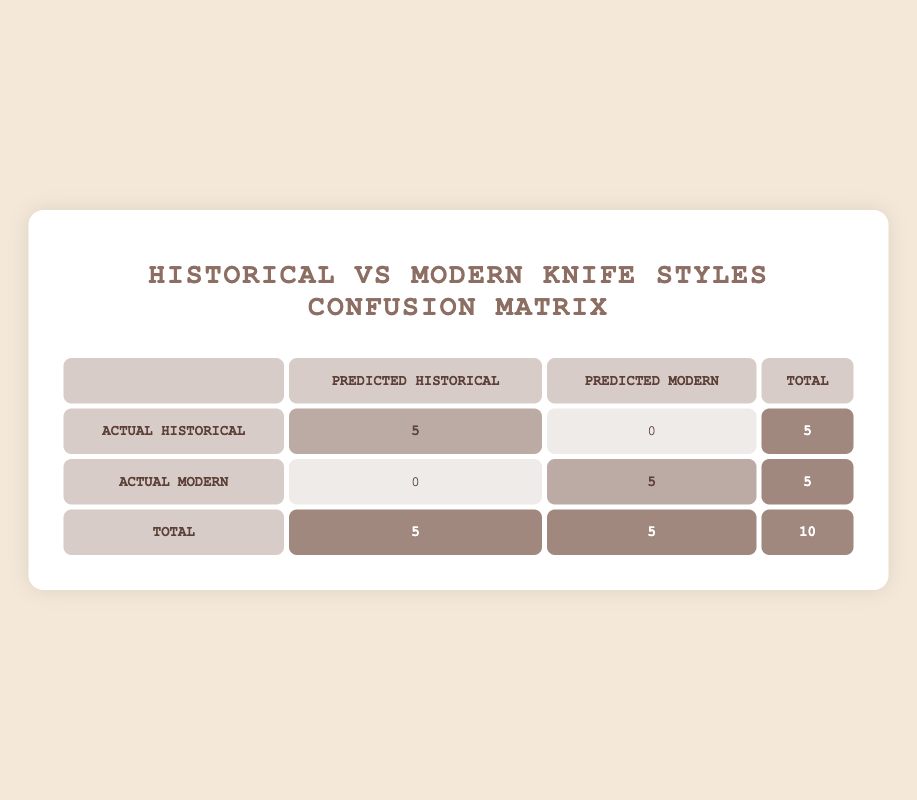What is the total number of historical knives sold? The table shows that under "Actual Historical," there are 5 entries marked as "Predicted Historical," which indicates that 5 historical knives were sold.
Answer: 5 How many modern reproduction knives were sold? The table indicates that under "Actual Modern," there are 5 entries marked as "Predicted Modern," meaning 5 modern reproduction knives were sold.
Answer: 5 Were any historical knives misclassified as modern reproductions? The table indicates that there are 0 historical knives predicted as modern (0 under "Predicted Modern" for "Actual Historical"). Thus, no historical knives were misclassified.
Answer: No What is the ratio of historical knives sold to modern reproductions sold? The total historical knives sold is 5 and modern reproductions sold is also 5. The ratio is calculated as 5:5, which simplifies to 1:1.
Answer: 1:1 What is the total number of knives sold overall? The total number of knives sold combines both historical and modern knives, which are 5 historical and 5 modern. Therefore, the total is 5 + 5 = 10.
Answer: 10 What percentage of the total sales were historical knives? The total sales are 10 knives, with 5 being historical. To calculate the percentage, (5 historical / 10 total) * 100 = 50%.
Answer: 50% Is it true that all knives sold in this auction were either historical or modern reproductions? According to the table, all knives fall under either historical or modern categories, indicating that no other types are present. Therefore, it is true.
Answer: Yes What would be the result if one historical knife had been misclassified as a modern reproduction? If one historical knife was misclassified, "Actual Historical" would have 4, "Predicted Modern" would increase to 1. This would indicate a confusion, and the total for historical would then be 4, while modern would remain 5.
Answer: 4 historical, 5 modern 